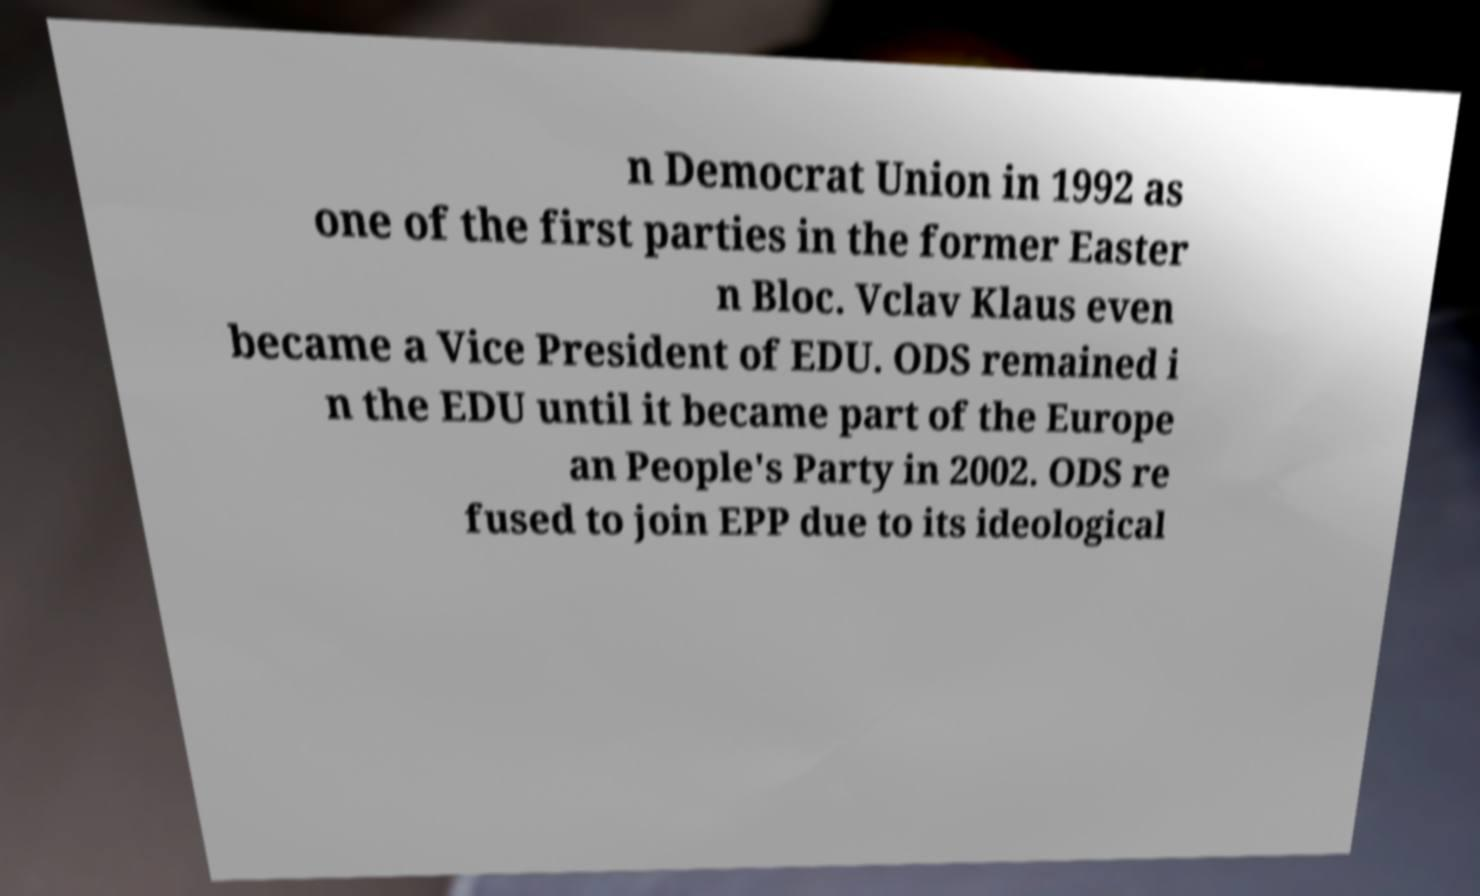There's text embedded in this image that I need extracted. Can you transcribe it verbatim? n Democrat Union in 1992 as one of the first parties in the former Easter n Bloc. Vclav Klaus even became a Vice President of EDU. ODS remained i n the EDU until it became part of the Europe an People's Party in 2002. ODS re fused to join EPP due to its ideological 